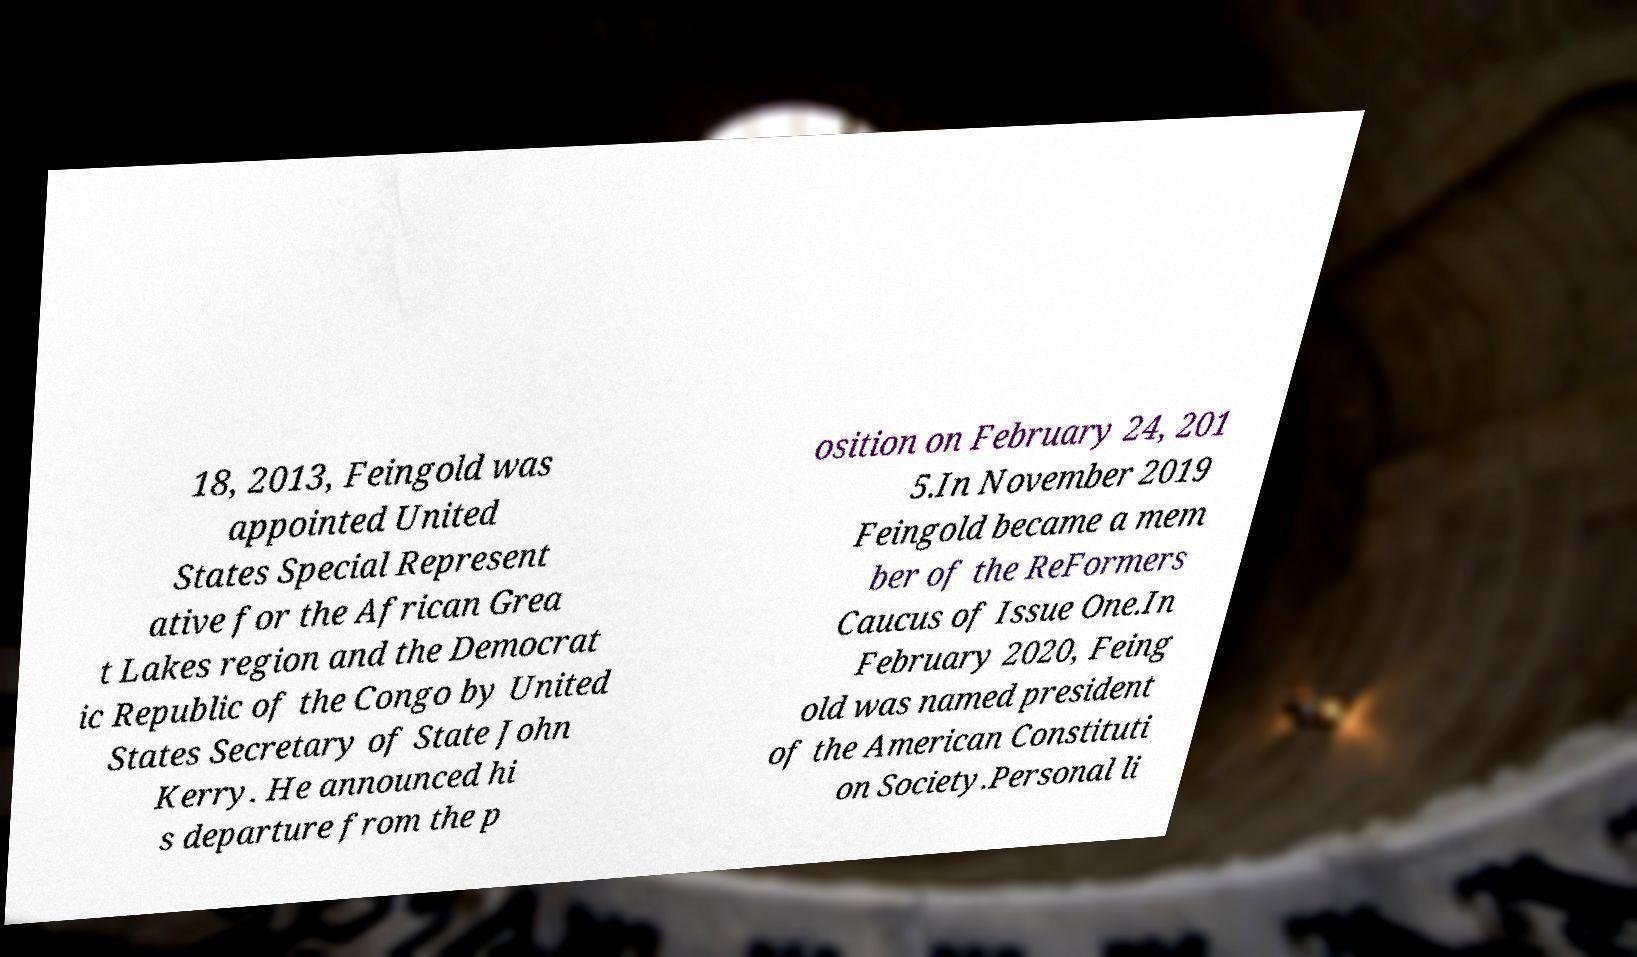Can you accurately transcribe the text from the provided image for me? 18, 2013, Feingold was appointed United States Special Represent ative for the African Grea t Lakes region and the Democrat ic Republic of the Congo by United States Secretary of State John Kerry. He announced hi s departure from the p osition on February 24, 201 5.In November 2019 Feingold became a mem ber of the ReFormers Caucus of Issue One.In February 2020, Feing old was named president of the American Constituti on Society.Personal li 